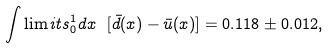Convert formula to latex. <formula><loc_0><loc_0><loc_500><loc_500>\int \lim i t s _ { 0 } ^ { 1 } d x \ [ \bar { d } ( x ) - \bar { u } ( x ) ] = 0 . 1 1 8 \pm 0 . 0 1 2 ,</formula> 